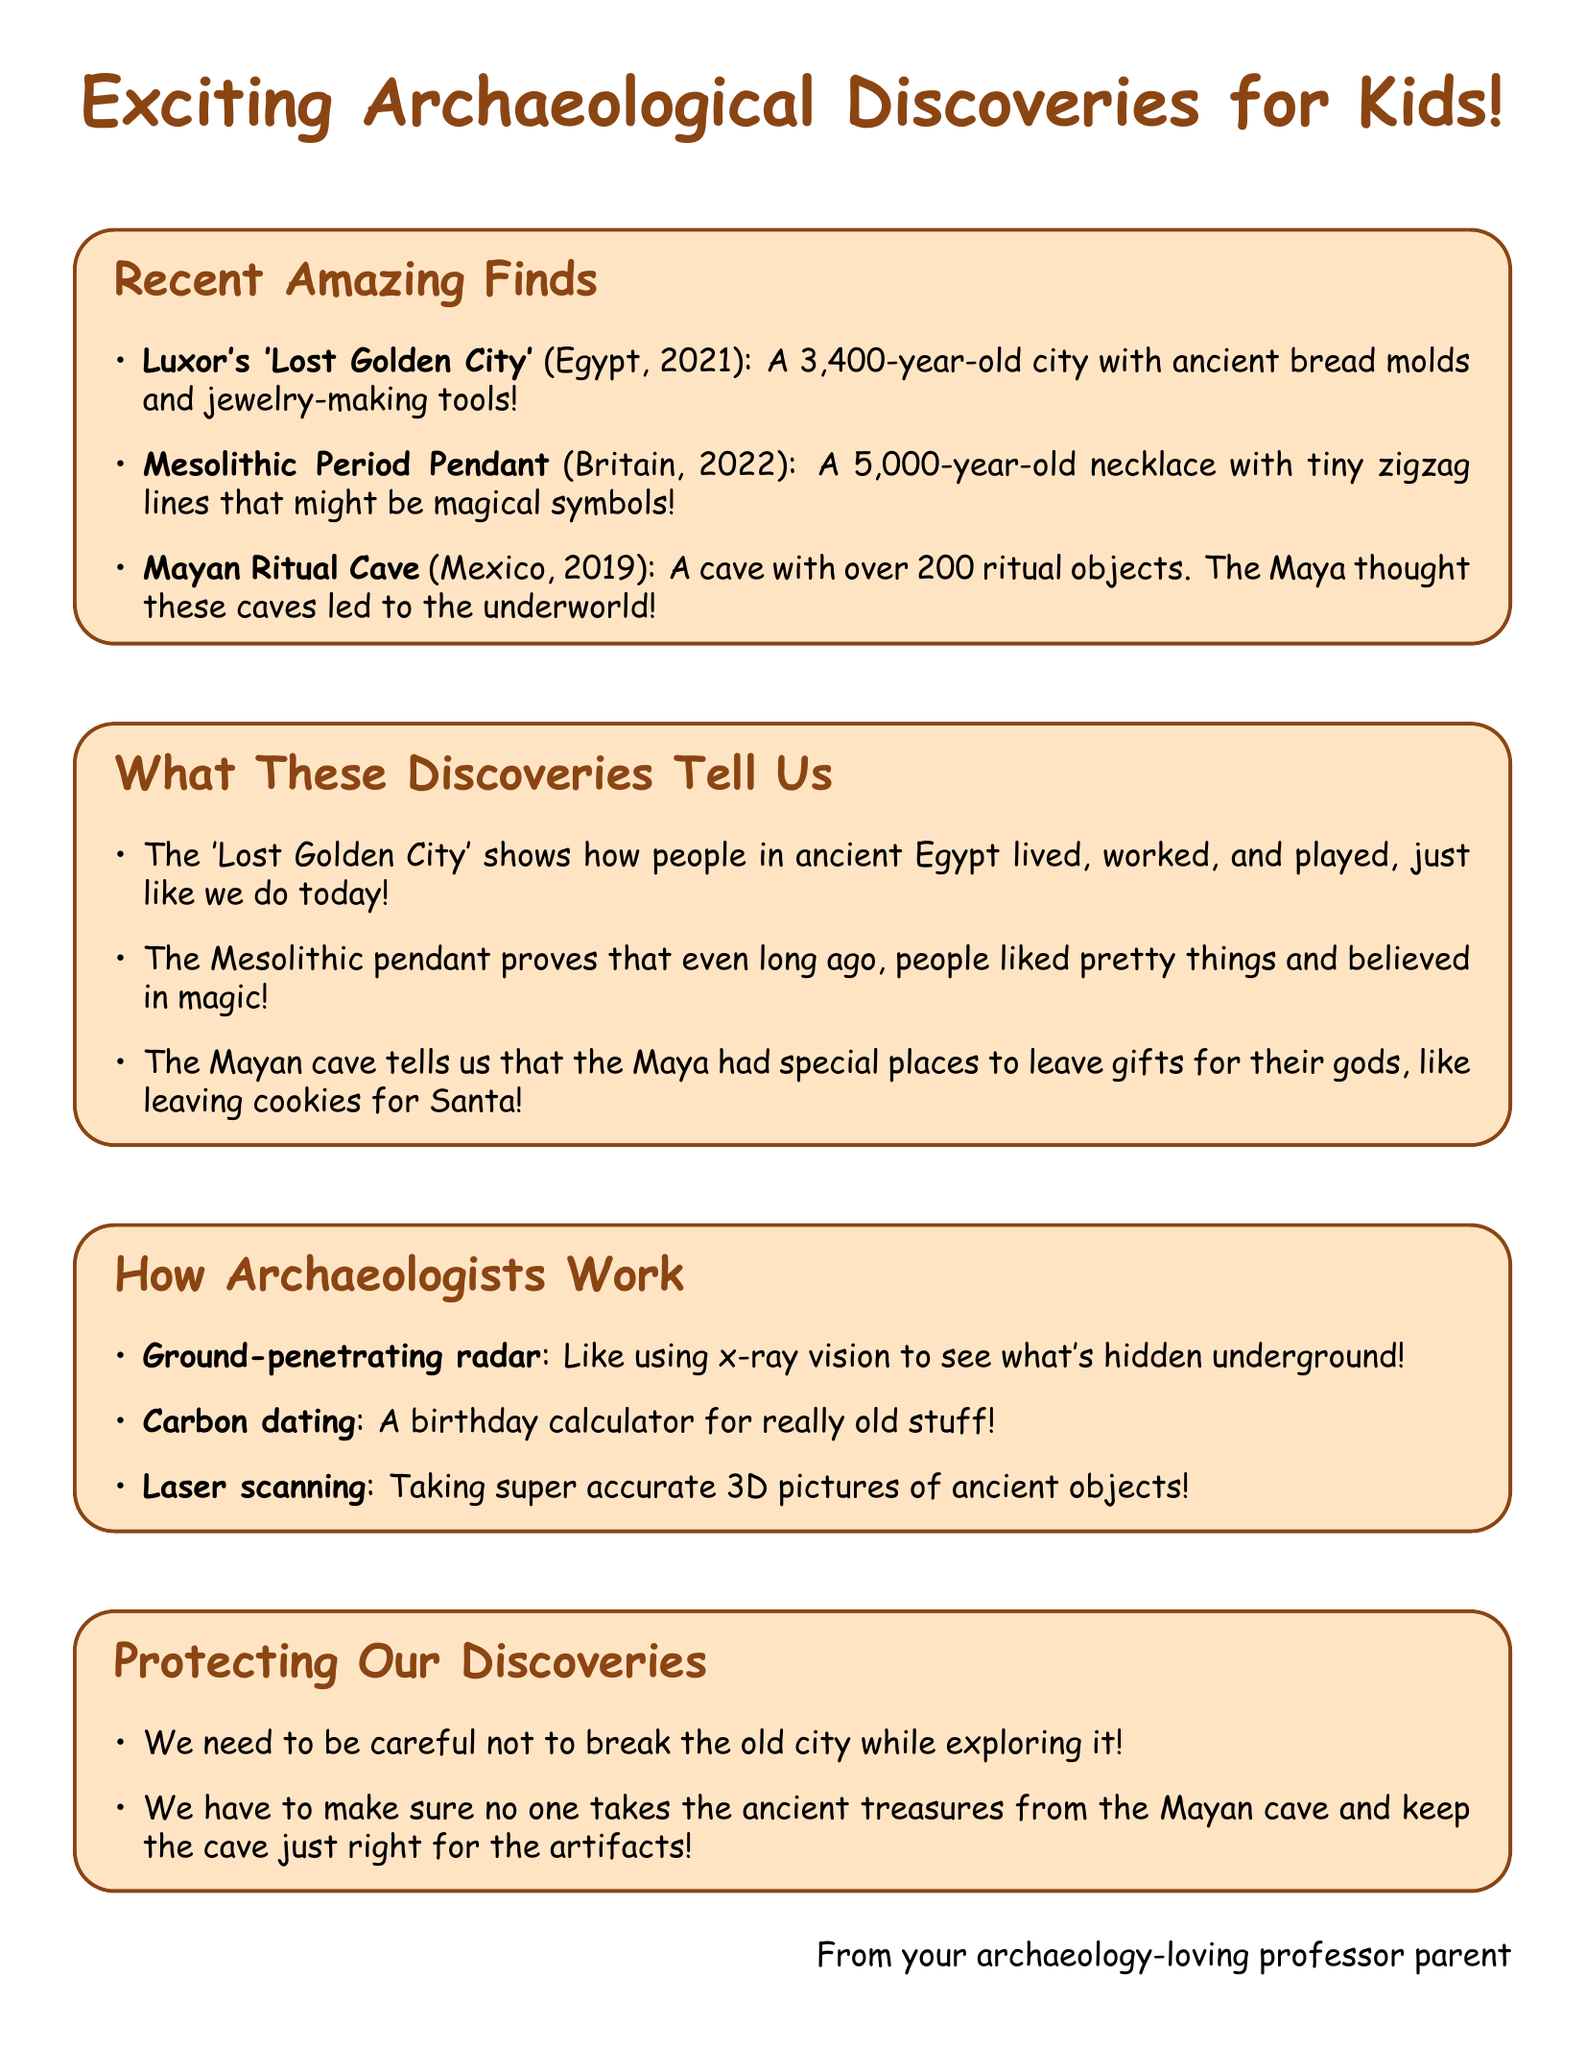What is the name of the ancient city discovered in Egypt? The document states that the discovery is known as Luxor's 'Lost Golden City'.
Answer: Luxor's 'Lost Golden City' How old is the Mesolithic Period Pendant? The document provides the age of the pendant as 5,000 years old.
Answer: 5,000 years old In what year was Luxor's 'Lost Golden City' discovered? The document specifies that it was discovered in 2021.
Answer: 2021 What kind of objects were found in the Mayan Ritual Cave? The document mentions that over 200 ritual objects, including incense burners and ceramic vessels, were found.
Answer: Over 200 ritual objects What civilization is associated with the 'Lost Golden City'? The document states that the civilization is Ancient Egypt.
Answer: Ancient Egypt What technique helps determine the age of organic materials? The document refers to this technique as carbon dating.
Answer: Carbon dating Why did the Maya believe caves were important? The document explains that the Maya believed these caves were entrances to the underworld.
Answer: Entrances to the underworld What was a challenge in preserving Luxor's 'Lost Golden City'? The document mentions protecting mud-brick structures from erosion and tourism impact.
Answer: Erosion and tourism impact What method do archaeologists use to see what is hidden underground? The document describes this method as ground-penetrating radar.
Answer: Ground-penetrating radar 